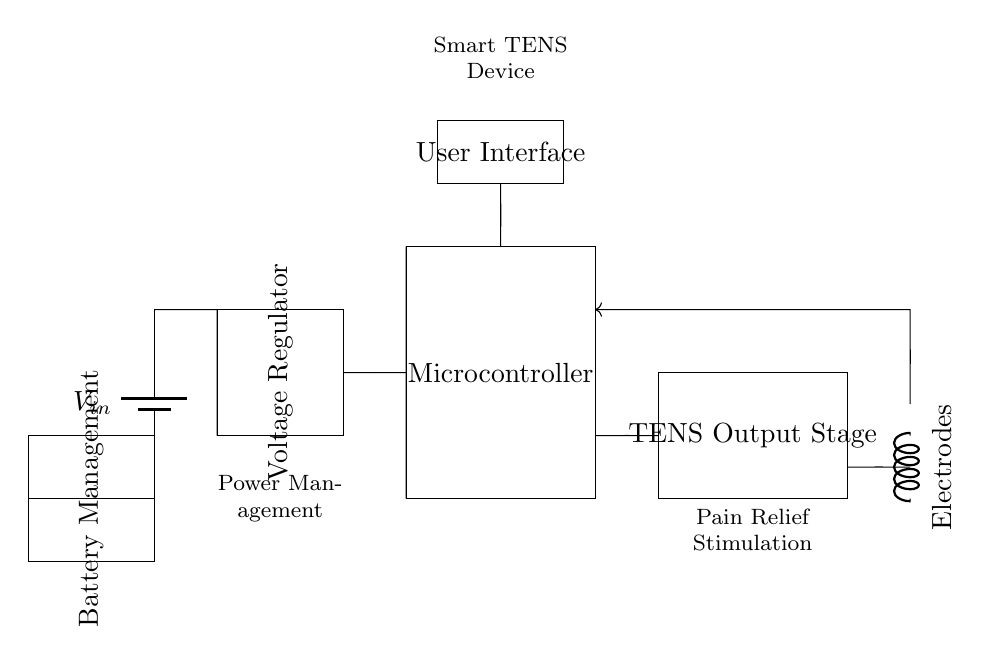What is the name of the power supply component in this circuit? The power supply is a battery, which is typically used to provide the necessary voltage to the circuit. In this diagram, it is labeled as V_in.
Answer: battery What is the purpose of the voltage regulator in this circuit? The voltage regulator ensures that the output voltage remains stable despite variations in the input voltage or load current, which is crucial for consistent performance of the circuit.
Answer: stable voltage Where does the microcontroller receive power from? The microcontroller receives power from the voltage regulator, as indicated by the connection between these two components in the diagram.
Answer: voltage regulator What is the main function of the TENS output stage? The TENS output stage is responsible for generating the electrical impulses that are delivered to the electrodes for pain relief stimulation.
Answer: generate impulses How does the feedback loop in the circuit operate? The feedback loop connects the electrodes back to the microcontroller and ensures that the TENS stimulation can be adjusted based on user feedback or monitoring, which is essential for optimizing pain relief.
Answer: adjusts stimulation Which component is responsible for managing the battery in this design? The component responsible for battery management in this circuit is labeled as battery management; it regulates charging and discharging of the battery for efficient operation.
Answer: battery management How are the electrodes connected in the circuit? The electrodes are connected from the TENS output stage; they receive electrical impulses directly from it, as indicated by the short connection in the diagram.
Answer: TENS output stage 